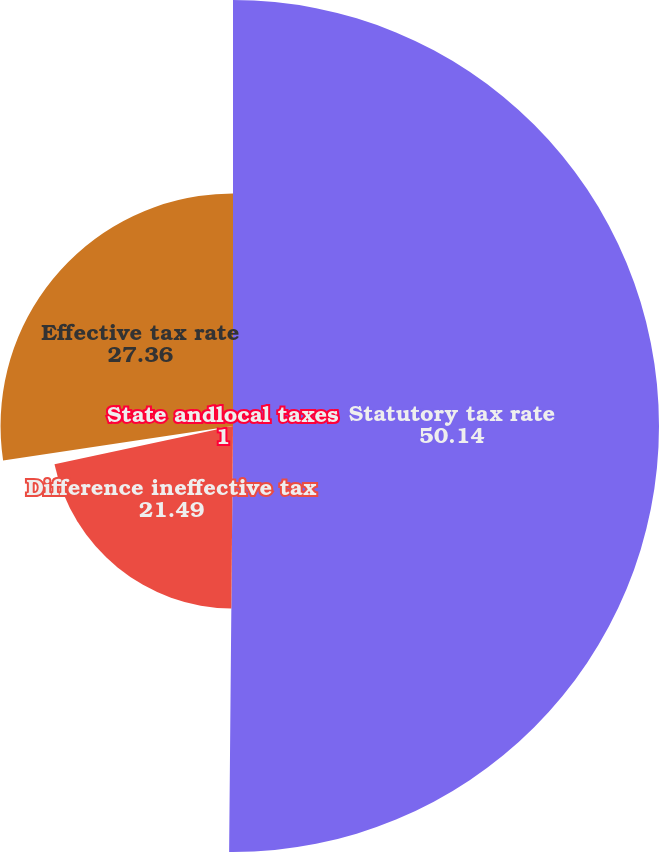<chart> <loc_0><loc_0><loc_500><loc_500><pie_chart><fcel>Statutory tax rate<fcel>Difference ineffective tax<fcel>State andlocal taxes<fcel>Effective tax rate<nl><fcel>50.14%<fcel>21.49%<fcel>1.0%<fcel>27.36%<nl></chart> 